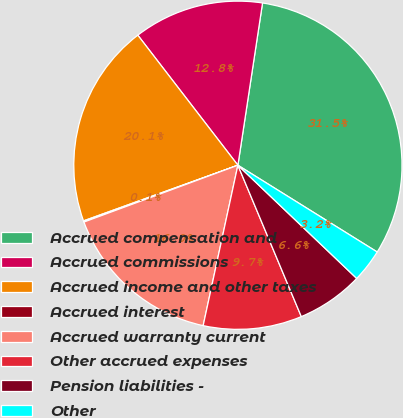Convert chart to OTSL. <chart><loc_0><loc_0><loc_500><loc_500><pie_chart><fcel>Accrued compensation and<fcel>Accrued commissions<fcel>Accrued income and other taxes<fcel>Accrued interest<fcel>Accrued warranty current<fcel>Other accrued expenses<fcel>Pension liabilities -<fcel>Other<nl><fcel>31.47%<fcel>12.84%<fcel>20.07%<fcel>0.12%<fcel>15.98%<fcel>9.71%<fcel>6.57%<fcel>3.25%<nl></chart> 